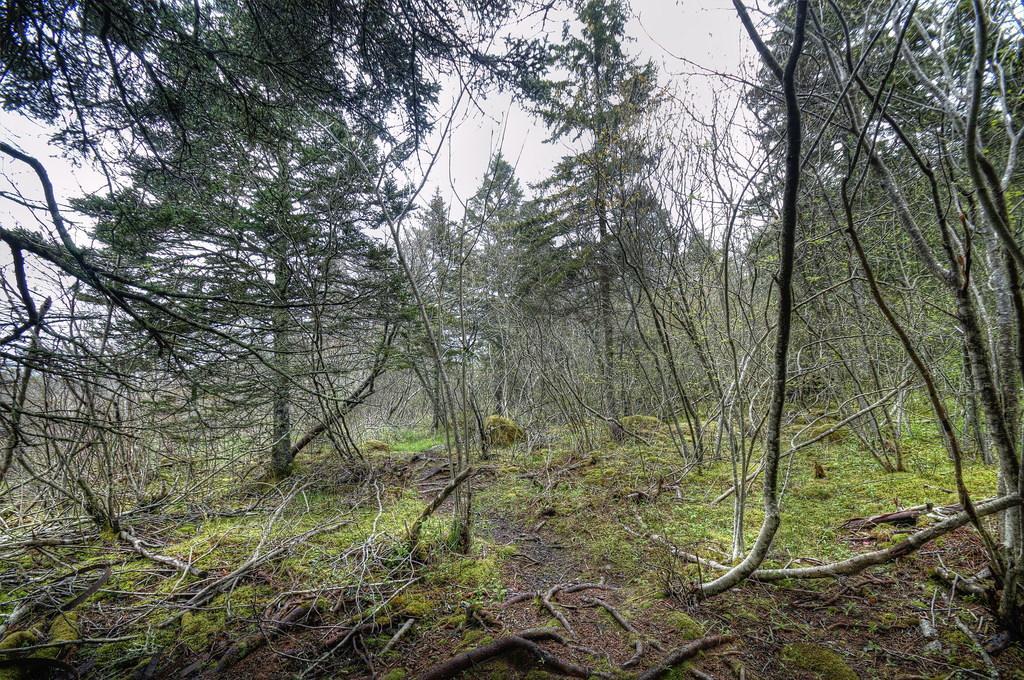Describe this image in one or two sentences. This image is taken outdoors. At the bottom of the image there is a ground with grass on it. In this image there are many trees. At the top of the image there is a sky. 